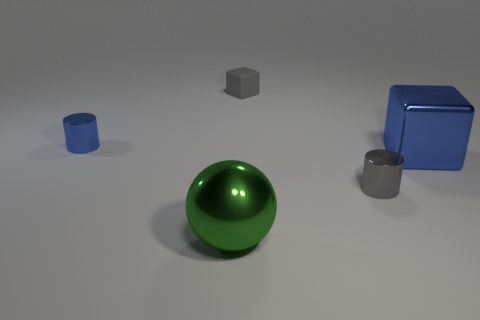Add 1 small blue things. How many objects exist? 6 Subtract all cylinders. How many objects are left? 3 Add 4 tiny blocks. How many tiny blocks are left? 5 Add 2 large blue matte blocks. How many large blue matte blocks exist? 2 Subtract 0 green blocks. How many objects are left? 5 Subtract all big green cylinders. Subtract all big blue metal cubes. How many objects are left? 4 